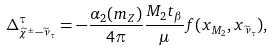Convert formula to latex. <formula><loc_0><loc_0><loc_500><loc_500>\Delta _ { \widetilde { \chi } ^ { \pm } - \widetilde { \nu } _ { \tau } } ^ { \tau } = - \frac { \alpha _ { 2 } ( m _ { Z } ) } { 4 \pi } \frac { M _ { 2 } t _ { \beta } } { \mu } f ( x _ { M _ { 2 } } , x _ { \widetilde { \nu } _ { \tau } } ) ,</formula> 